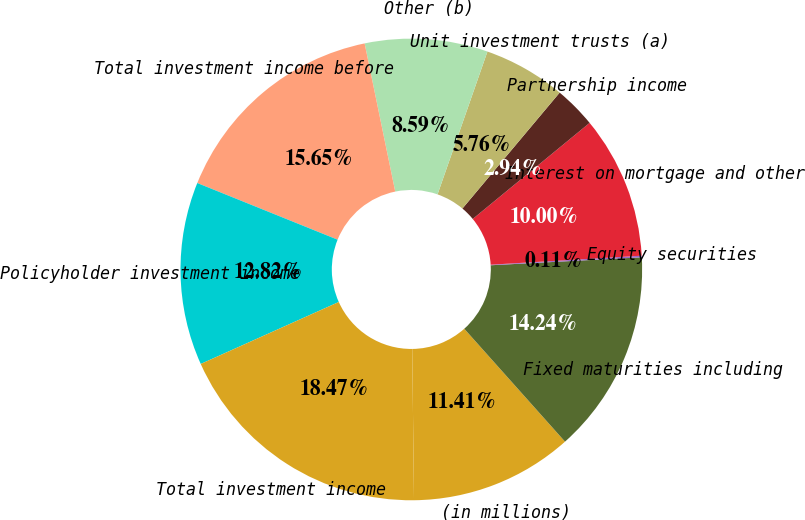Convert chart to OTSL. <chart><loc_0><loc_0><loc_500><loc_500><pie_chart><fcel>(in millions)<fcel>Fixed maturities including<fcel>Equity securities<fcel>Interest on mortgage and other<fcel>Partnership income<fcel>Unit investment trusts (a)<fcel>Other (b)<fcel>Total investment income before<fcel>Policyholder investment income<fcel>Total investment income<nl><fcel>11.41%<fcel>14.24%<fcel>0.11%<fcel>10.0%<fcel>2.94%<fcel>5.76%<fcel>8.59%<fcel>15.65%<fcel>12.82%<fcel>18.47%<nl></chart> 